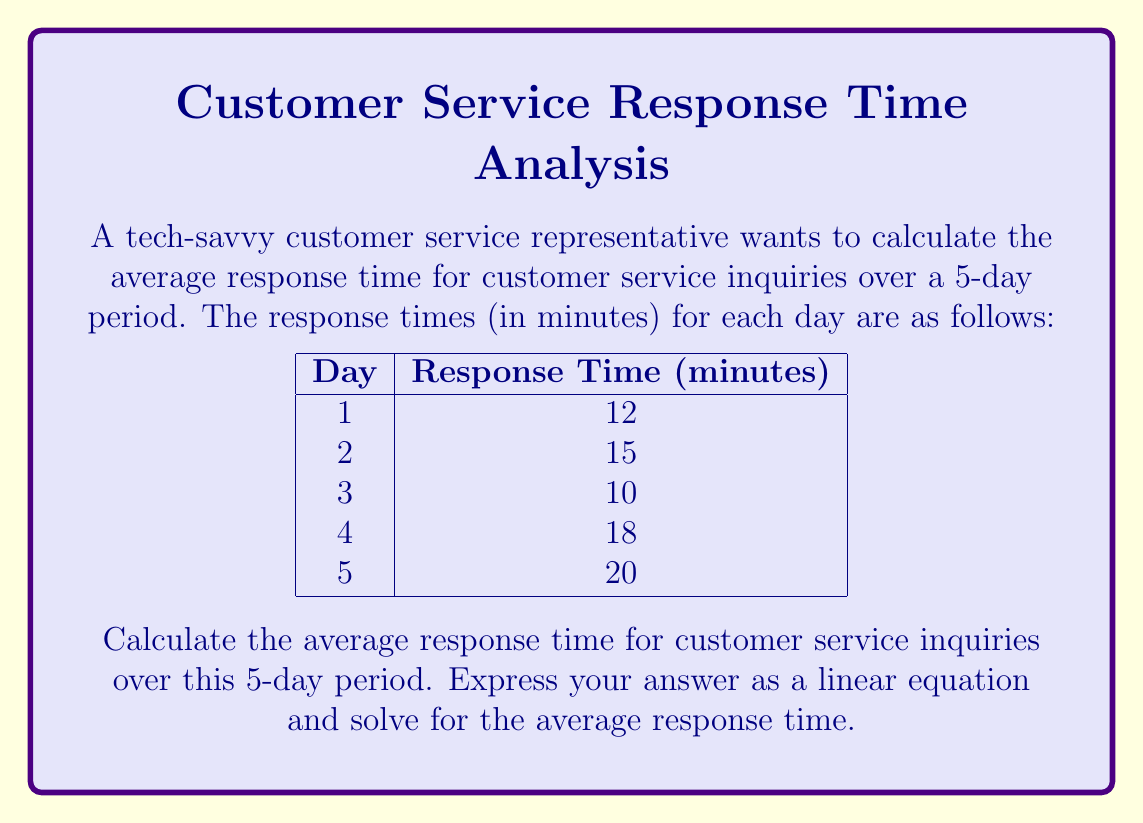Show me your answer to this math problem. To solve this problem, we'll use the concept of arithmetic mean, which is represented by a linear equation. Here's the step-by-step solution:

1) The formula for calculating the arithmetic mean (average) is:

   $$\bar{x} = \frac{\sum_{i=1}^{n} x_i}{n}$$

   Where $\bar{x}$ is the average, $x_i$ are the individual values, and $n$ is the number of values.

2) In this case, we have:
   $x_1 = 12$, $x_2 = 15$, $x_3 = 10$, $x_4 = 18$, $x_5 = 20$, and $n = 5$

3) Let's substitute these values into our equation:

   $$\bar{x} = \frac{12 + 15 + 10 + 18 + 20}{5}$$

4) Now, let's solve the equation:
   
   $$\bar{x} = \frac{75}{5}$$

5) Simplify:

   $$\bar{x} = 15$$

Therefore, the average response time for customer service inquiries over the 5-day period is 15 minutes.
Answer: The average response time is 15 minutes. 